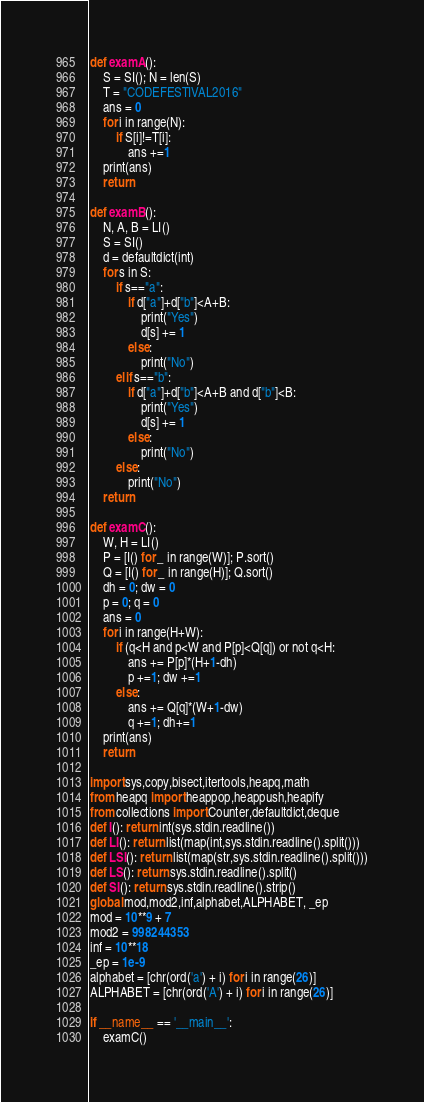Convert code to text. <code><loc_0><loc_0><loc_500><loc_500><_Python_>def examA():
    S = SI(); N = len(S)
    T = "CODEFESTIVAL2016"
    ans = 0
    for i in range(N):
        if S[i]!=T[i]:
            ans +=1
    print(ans)
    return

def examB():
    N, A, B = LI()
    S = SI()
    d = defaultdict(int)
    for s in S:
        if s=="a":
            if d["a"]+d["b"]<A+B:
                print("Yes")
                d[s] += 1
            else:
                print("No")
        elif s=="b":
            if d["a"]+d["b"]<A+B and d["b"]<B:
                print("Yes")
                d[s] += 1
            else:
                print("No")
        else:
            print("No")
    return

def examC():
    W, H = LI()
    P = [I() for _ in range(W)]; P.sort()
    Q = [I() for _ in range(H)]; Q.sort()
    dh = 0; dw = 0
    p = 0; q = 0
    ans = 0
    for i in range(H+W):
        if (q<H and p<W and P[p]<Q[q]) or not q<H:
            ans += P[p]*(H+1-dh)
            p +=1; dw +=1
        else:
            ans += Q[q]*(W+1-dw)
            q +=1; dh+=1
    print(ans)
    return

import sys,copy,bisect,itertools,heapq,math
from heapq import heappop,heappush,heapify
from collections import Counter,defaultdict,deque
def I(): return int(sys.stdin.readline())
def LI(): return list(map(int,sys.stdin.readline().split()))
def LSI(): return list(map(str,sys.stdin.readline().split()))
def LS(): return sys.stdin.readline().split()
def SI(): return sys.stdin.readline().strip()
global mod,mod2,inf,alphabet,ALPHABET, _ep
mod = 10**9 + 7
mod2 = 998244353
inf = 10**18
_ep = 1e-9
alphabet = [chr(ord('a') + i) for i in range(26)]
ALPHABET = [chr(ord('A') + i) for i in range(26)]

if __name__ == '__main__':
    examC()
</code> 